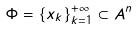Convert formula to latex. <formula><loc_0><loc_0><loc_500><loc_500>\Phi = \{ x _ { k } \} _ { k = 1 } ^ { + \infty } \subset A ^ { n }</formula> 